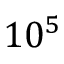Convert formula to latex. <formula><loc_0><loc_0><loc_500><loc_500>1 0 ^ { 5 }</formula> 